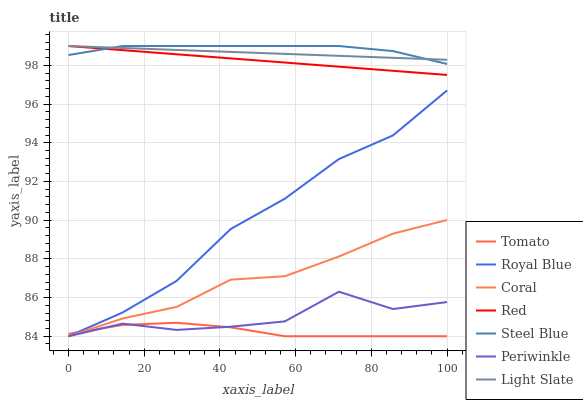Does Tomato have the minimum area under the curve?
Answer yes or no. Yes. Does Steel Blue have the maximum area under the curve?
Answer yes or no. Yes. Does Light Slate have the minimum area under the curve?
Answer yes or no. No. Does Light Slate have the maximum area under the curve?
Answer yes or no. No. Is Red the smoothest?
Answer yes or no. Yes. Is Periwinkle the roughest?
Answer yes or no. Yes. Is Light Slate the smoothest?
Answer yes or no. No. Is Light Slate the roughest?
Answer yes or no. No. Does Tomato have the lowest value?
Answer yes or no. Yes. Does Light Slate have the lowest value?
Answer yes or no. No. Does Red have the highest value?
Answer yes or no. Yes. Does Coral have the highest value?
Answer yes or no. No. Is Coral less than Light Slate?
Answer yes or no. Yes. Is Light Slate greater than Royal Blue?
Answer yes or no. Yes. Does Coral intersect Periwinkle?
Answer yes or no. Yes. Is Coral less than Periwinkle?
Answer yes or no. No. Is Coral greater than Periwinkle?
Answer yes or no. No. Does Coral intersect Light Slate?
Answer yes or no. No. 